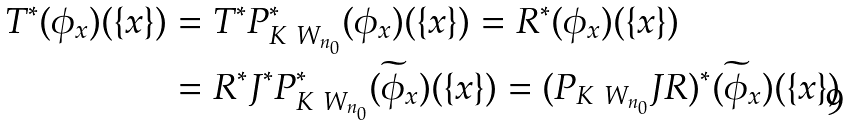<formula> <loc_0><loc_0><loc_500><loc_500>T ^ { * } ( \phi _ { x } ) ( \{ x \} ) & = T ^ { * } P _ { K \ W _ { n _ { 0 } } } ^ { * } ( \phi _ { x } ) ( \{ x \} ) = R ^ { * } ( \phi _ { x } ) ( \{ x \} ) \\ & = R ^ { * } J ^ { * } P _ { K \ W _ { n _ { 0 } } } ^ { * } ( \widetilde { \phi } _ { x } ) ( \{ x \} ) = ( P _ { K \ W _ { n _ { 0 } } } J R ) ^ { * } ( \widetilde { \phi } _ { x } ) ( \{ x \} )</formula> 